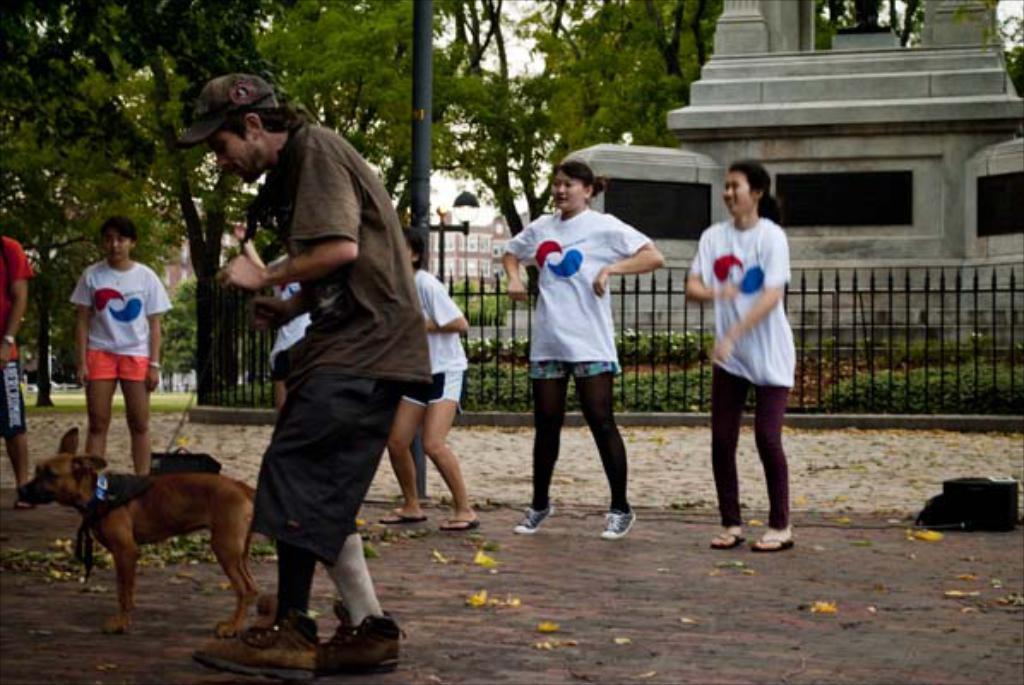In one or two sentences, can you explain what this image depicts? In this picture we can see some persons are standing on the road. There is a dog. On the background there are trees and this is pole. Here we can see a building and this is fence. 